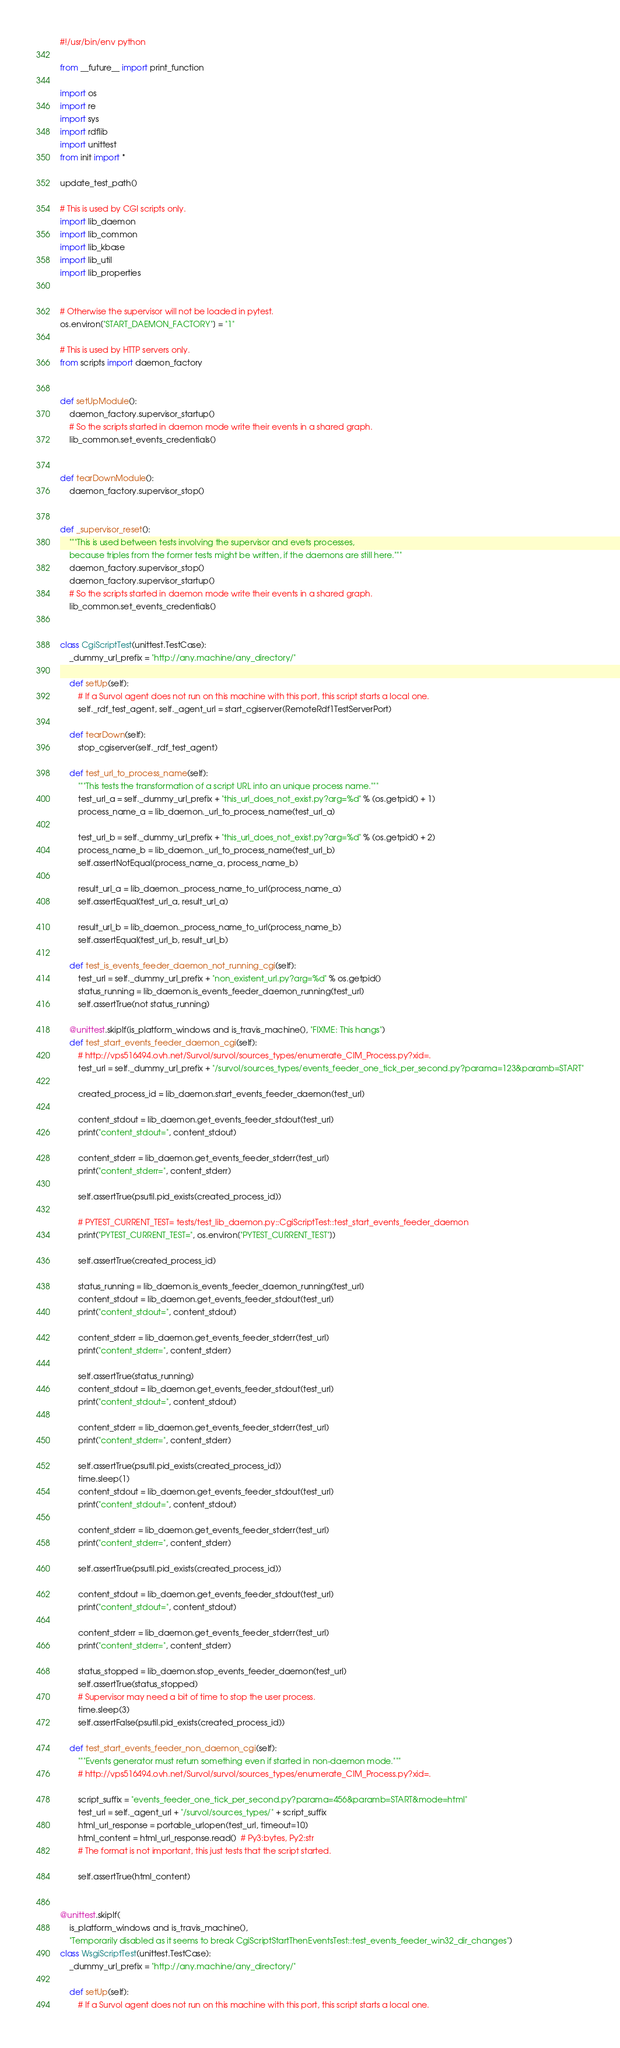<code> <loc_0><loc_0><loc_500><loc_500><_Python_>#!/usr/bin/env python

from __future__ import print_function

import os
import re
import sys
import rdflib
import unittest
from init import *

update_test_path()

# This is used by CGI scripts only.
import lib_daemon
import lib_common
import lib_kbase
import lib_util
import lib_properties


# Otherwise the supervisor will not be loaded in pytest.
os.environ["START_DAEMON_FACTORY"] = "1"

# This is used by HTTP servers only.
from scripts import daemon_factory


def setUpModule():
    daemon_factory.supervisor_startup()
    # So the scripts started in daemon mode write their events in a shared graph.
    lib_common.set_events_credentials()


def tearDownModule():
    daemon_factory.supervisor_stop()


def _supervisor_reset():
    """This is used between tests involving the supervisor and evets processes,
    because triples from the former tests might be written, if the daemons are still here."""
    daemon_factory.supervisor_stop()
    daemon_factory.supervisor_startup()
    # So the scripts started in daemon mode write their events in a shared graph.
    lib_common.set_events_credentials()


class CgiScriptTest(unittest.TestCase):
    _dummy_url_prefix = "http://any.machine/any_directory/"

    def setUp(self):
        # If a Survol agent does not run on this machine with this port, this script starts a local one.
        self._rdf_test_agent, self._agent_url = start_cgiserver(RemoteRdf1TestServerPort)

    def tearDown(self):
        stop_cgiserver(self._rdf_test_agent)

    def test_url_to_process_name(self):
        """This tests the transformation of a script URL into an unique process name."""
        test_url_a = self._dummy_url_prefix + "this_url_does_not_exist.py?arg=%d" % (os.getpid() + 1)
        process_name_a = lib_daemon._url_to_process_name(test_url_a)

        test_url_b = self._dummy_url_prefix + "this_url_does_not_exist.py?arg=%d" % (os.getpid() + 2)
        process_name_b = lib_daemon._url_to_process_name(test_url_b)
        self.assertNotEqual(process_name_a, process_name_b)

        result_url_a = lib_daemon._process_name_to_url(process_name_a)
        self.assertEqual(test_url_a, result_url_a)

        result_url_b = lib_daemon._process_name_to_url(process_name_b)
        self.assertEqual(test_url_b, result_url_b)

    def test_is_events_feeder_daemon_not_running_cgi(self):
        test_url = self._dummy_url_prefix + "non_existent_url.py?arg=%d" % os.getpid()
        status_running = lib_daemon.is_events_feeder_daemon_running(test_url)
        self.assertTrue(not status_running)

    @unittest.skipIf(is_platform_windows and is_travis_machine(), "FIXME: This hangs")
    def test_start_events_feeder_daemon_cgi(self):
        # http://vps516494.ovh.net/Survol/survol/sources_types/enumerate_CIM_Process.py?xid=.
        test_url = self._dummy_url_prefix + "/survol/sources_types/events_feeder_one_tick_per_second.py?parama=123&paramb=START"

        created_process_id = lib_daemon.start_events_feeder_daemon(test_url)

        content_stdout = lib_daemon.get_events_feeder_stdout(test_url)
        print("content_stdout=", content_stdout)

        content_stderr = lib_daemon.get_events_feeder_stderr(test_url)
        print("content_stderr=", content_stderr)

        self.assertTrue(psutil.pid_exists(created_process_id))

        # PYTEST_CURRENT_TEST= tests/test_lib_daemon.py::CgiScriptTest::test_start_events_feeder_daemon
        print("PYTEST_CURRENT_TEST=", os.environ["PYTEST_CURRENT_TEST"])

        self.assertTrue(created_process_id)

        status_running = lib_daemon.is_events_feeder_daemon_running(test_url)
        content_stdout = lib_daemon.get_events_feeder_stdout(test_url)
        print("content_stdout=", content_stdout)

        content_stderr = lib_daemon.get_events_feeder_stderr(test_url)
        print("content_stderr=", content_stderr)

        self.assertTrue(status_running)
        content_stdout = lib_daemon.get_events_feeder_stdout(test_url)
        print("content_stdout=", content_stdout)

        content_stderr = lib_daemon.get_events_feeder_stderr(test_url)
        print("content_stderr=", content_stderr)

        self.assertTrue(psutil.pid_exists(created_process_id))
        time.sleep(1)
        content_stdout = lib_daemon.get_events_feeder_stdout(test_url)
        print("content_stdout=", content_stdout)

        content_stderr = lib_daemon.get_events_feeder_stderr(test_url)
        print("content_stderr=", content_stderr)

        self.assertTrue(psutil.pid_exists(created_process_id))

        content_stdout = lib_daemon.get_events_feeder_stdout(test_url)
        print("content_stdout=", content_stdout)

        content_stderr = lib_daemon.get_events_feeder_stderr(test_url)
        print("content_stderr=", content_stderr)

        status_stopped = lib_daemon.stop_events_feeder_daemon(test_url)
        self.assertTrue(status_stopped)
        # Supervisor may need a bit of time to stop the user process.
        time.sleep(3)
        self.assertFalse(psutil.pid_exists(created_process_id))

    def test_start_events_feeder_non_daemon_cgi(self):
        """Events generator must return something even if started in non-daemon mode."""
        # http://vps516494.ovh.net/Survol/survol/sources_types/enumerate_CIM_Process.py?xid=.

        script_suffix = "events_feeder_one_tick_per_second.py?parama=456&paramb=START&mode=html"
        test_url = self._agent_url + "/survol/sources_types/" + script_suffix
        html_url_response = portable_urlopen(test_url, timeout=10)
        html_content = html_url_response.read()  # Py3:bytes, Py2:str
        # The format is not important, this just tests that the script started.

        self.assertTrue(html_content)


@unittest.skipIf(
    is_platform_windows and is_travis_machine(),
    "Temporarily disabled as it seems to break CgiScriptStartThenEventsTest::test_events_feeder_win32_dir_changes")
class WsgiScriptTest(unittest.TestCase):
    _dummy_url_prefix = "http://any.machine/any_directory/"

    def setUp(self):
        # If a Survol agent does not run on this machine with this port, this script starts a local one.</code> 